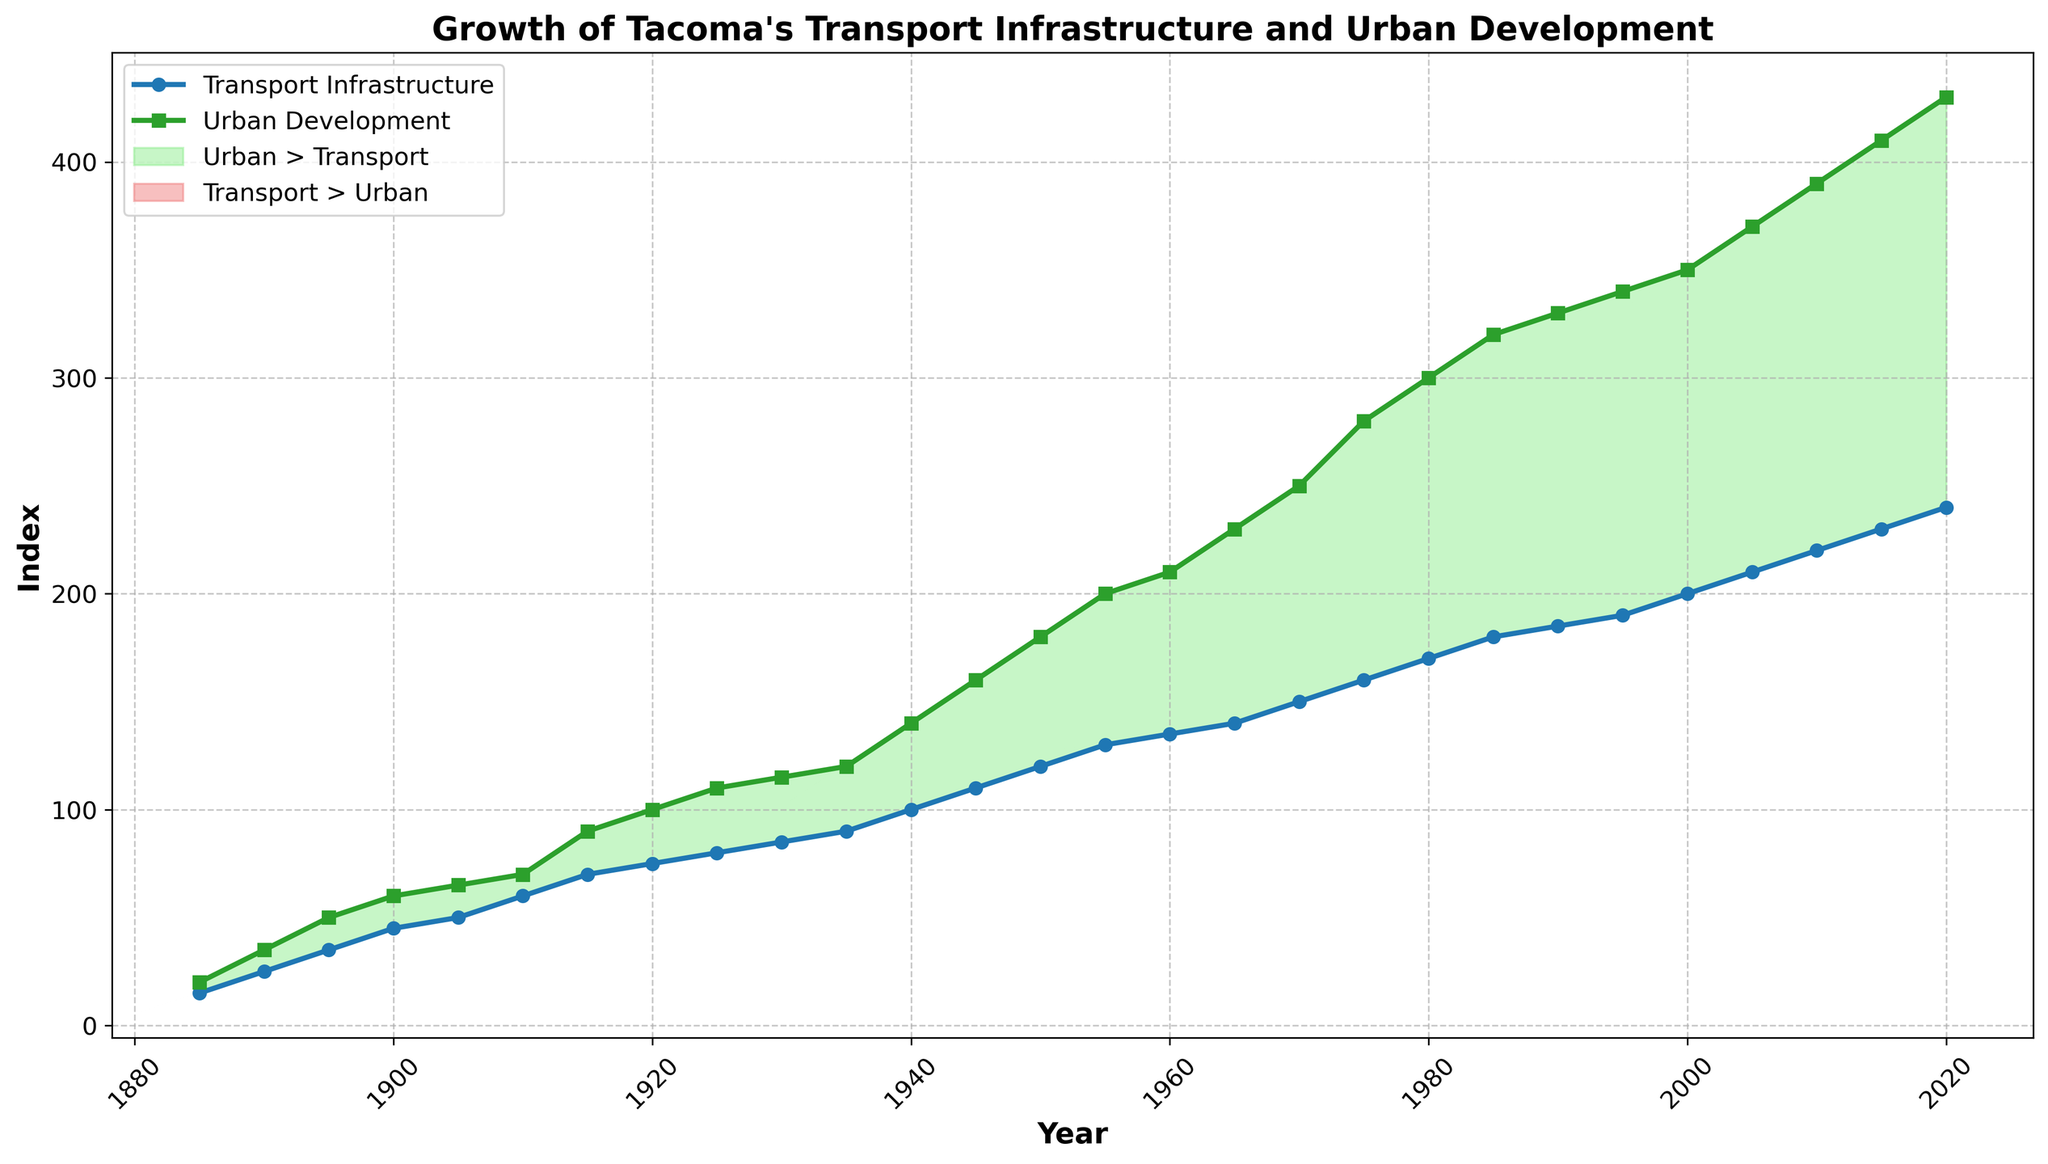What year did Urban Development first surpass Transport Infrastructure? To determine which year Urban Development first exceeds Transport Infrastructure, you have to compare their values year by year. As seen on the plot, the first instance this occurs is around 1900, where Urban Development is at 60, while Transport Infrastructure is at 45.
Answer: 1900 What is the difference between Urban Development and Transport Infrastructure in the year 2000? Identify the values for the year 2000: Urban Development is at 350 and Transport Infrastructure is at 200. The difference is obtained by subtracting Transport Infrastructure from Urban Development, yielding 350 - 200 = 150.
Answer: 150 During which period was the gap between Urban Development and Transport Infrastructure the largest? The gap can be visualized by the area filled between the two lines. The plot indicates the largest gap appears between 1940 and 1960, where Urban Development rises sharply compared to Transport Infrastructure. The peak of this gap appears around the early 1950s.
Answer: 1940-1960 When did the values of Transport Infrastructure and Urban Development grow at nearly the same rate? By observing the gradient of the two lines, they grow nearly parallel between 1885 and 1910. Both lines increase at similar rates during these years.
Answer: 1885-1910 Which section of the plot is filled with light green color, and what does it signify? The light green color fills the area where Urban Development values are greater than Transport Infrastructure values. This region stretches across the entire plot after the year 1885, showing that Urban Development consistently surpasses Transport Infrastructure.
Answer: Urban > Transport What was the rate of increase in Urban Development from 1885 to 1895? Check the values of Urban Development for both years: From 20 in 1885 to 50 in 1895. The rate of increase in these 10 years is (50 - 20) / 10 = 3 units per year.
Answer: 3 units per year How does the growth rate of Transport Infrastructure compare to Urban Development between 1980 and 2000? From the plot, Transport Infrastructure goes from 170 in 1980 to 200 in 2000, while Urban Development goes from 300 to 350. The respective growths are 30 for Transport Infrastructure and 50 for Urban Development. Urban Development grows faster during this period.
Answer: Urban Development grows faster In which years do Urban Development values remain static? Inspect the plot for any horizontal trends in Urban Development. Notably, there are no visible static (horizontal) segments; Urban Development has a consistent upward trend without any periods of stasis.
Answer: None Was there any year when Transport Infrastructure values decreased? No part of the Transport Infrastructure line trends downward in the plot. This indicates constant or increasing values without any decreases.
Answer: No 